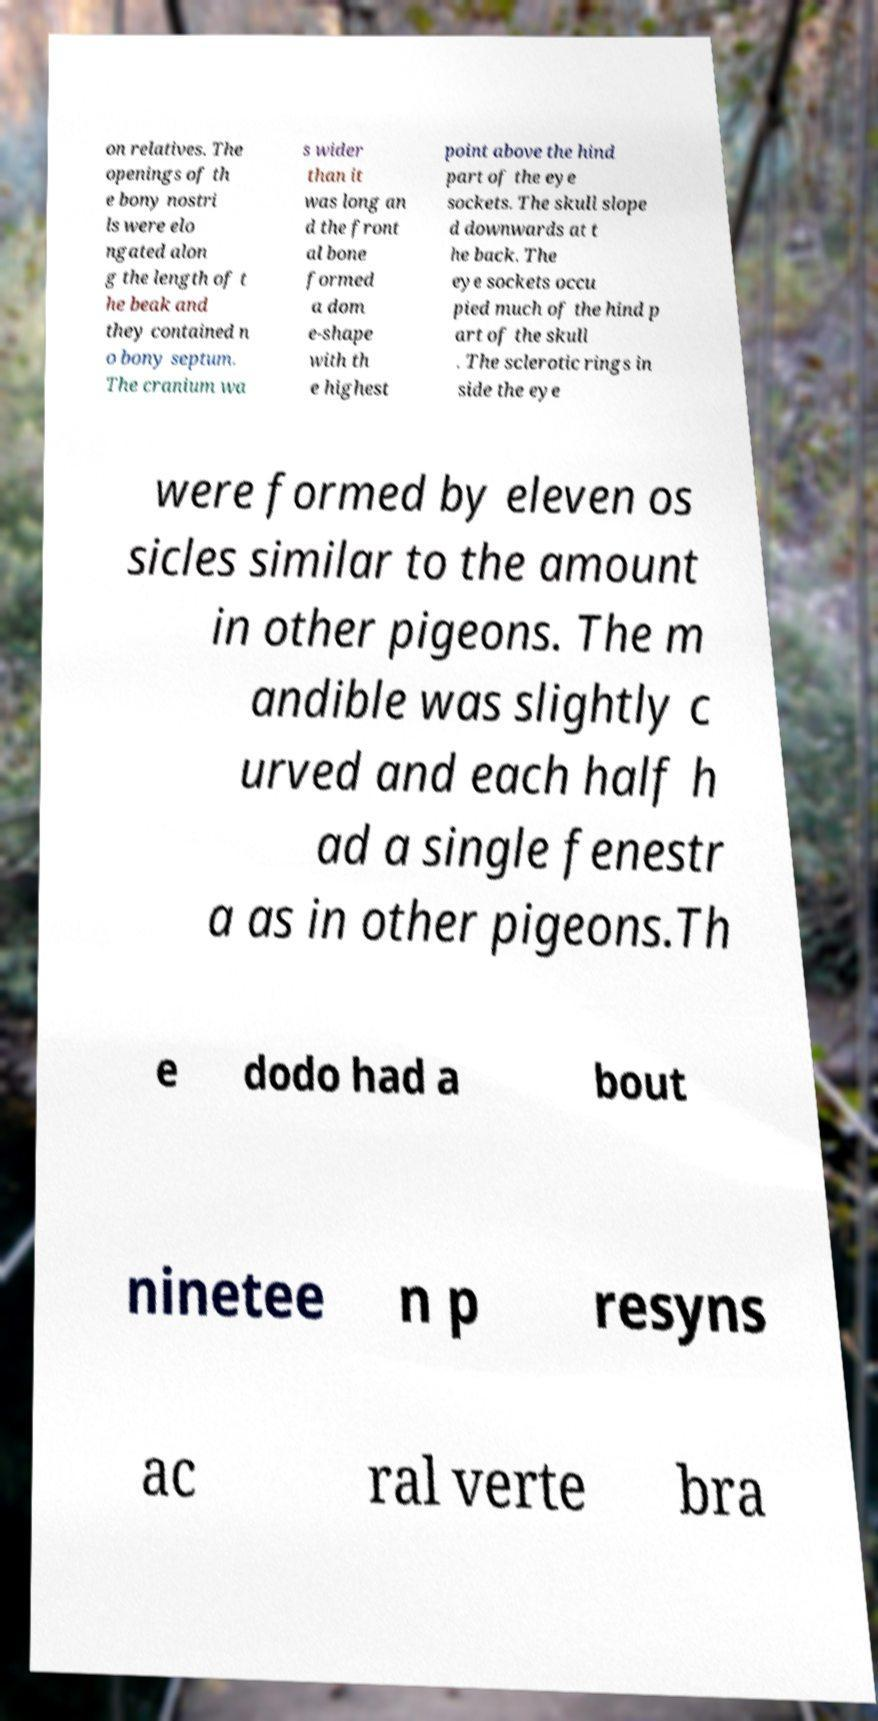Please identify and transcribe the text found in this image. on relatives. The openings of th e bony nostri ls were elo ngated alon g the length of t he beak and they contained n o bony septum. The cranium wa s wider than it was long an d the front al bone formed a dom e-shape with th e highest point above the hind part of the eye sockets. The skull slope d downwards at t he back. The eye sockets occu pied much of the hind p art of the skull . The sclerotic rings in side the eye were formed by eleven os sicles similar to the amount in other pigeons. The m andible was slightly c urved and each half h ad a single fenestr a as in other pigeons.Th e dodo had a bout ninetee n p resyns ac ral verte bra 